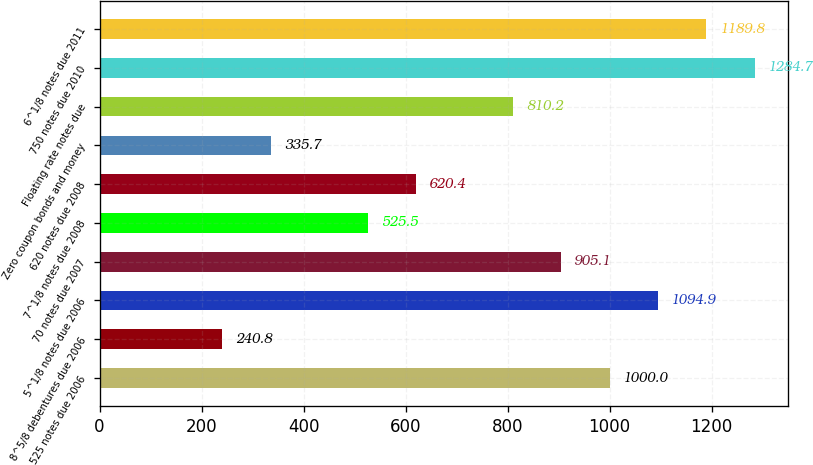Convert chart to OTSL. <chart><loc_0><loc_0><loc_500><loc_500><bar_chart><fcel>525 notes due 2006<fcel>8^5/8 debentures due 2006<fcel>5^1/8 notes due 2006<fcel>70 notes due 2007<fcel>7^1/8 notes due 2008<fcel>620 notes due 2008<fcel>Zero coupon bonds and money<fcel>Floating rate notes due<fcel>750 notes due 2010<fcel>6^1/8 notes due 2011<nl><fcel>1000<fcel>240.8<fcel>1094.9<fcel>905.1<fcel>525.5<fcel>620.4<fcel>335.7<fcel>810.2<fcel>1284.7<fcel>1189.8<nl></chart> 